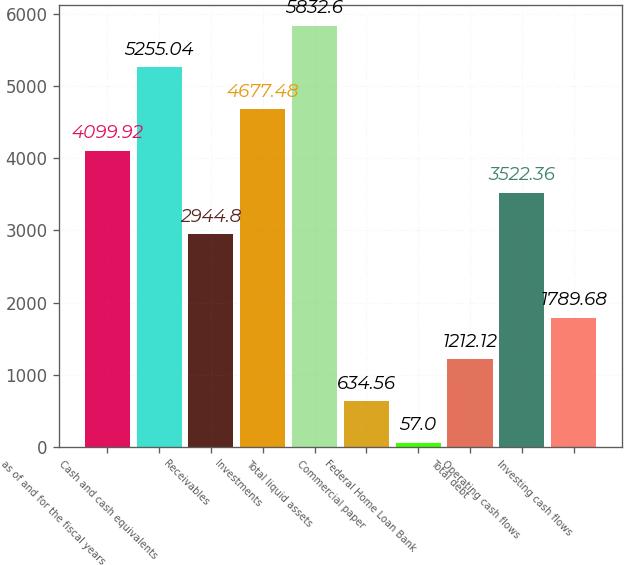Convert chart to OTSL. <chart><loc_0><loc_0><loc_500><loc_500><bar_chart><fcel>as of and for the fiscal years<fcel>Cash and cash equivalents<fcel>Receivables<fcel>Investments<fcel>Total liquid assets<fcel>Commercial paper<fcel>Federal Home Loan Bank<fcel>Total debt<fcel>Operating cash flows<fcel>Investing cash flows<nl><fcel>4099.92<fcel>5255.04<fcel>2944.8<fcel>4677.48<fcel>5832.6<fcel>634.56<fcel>57<fcel>1212.12<fcel>3522.36<fcel>1789.68<nl></chart> 